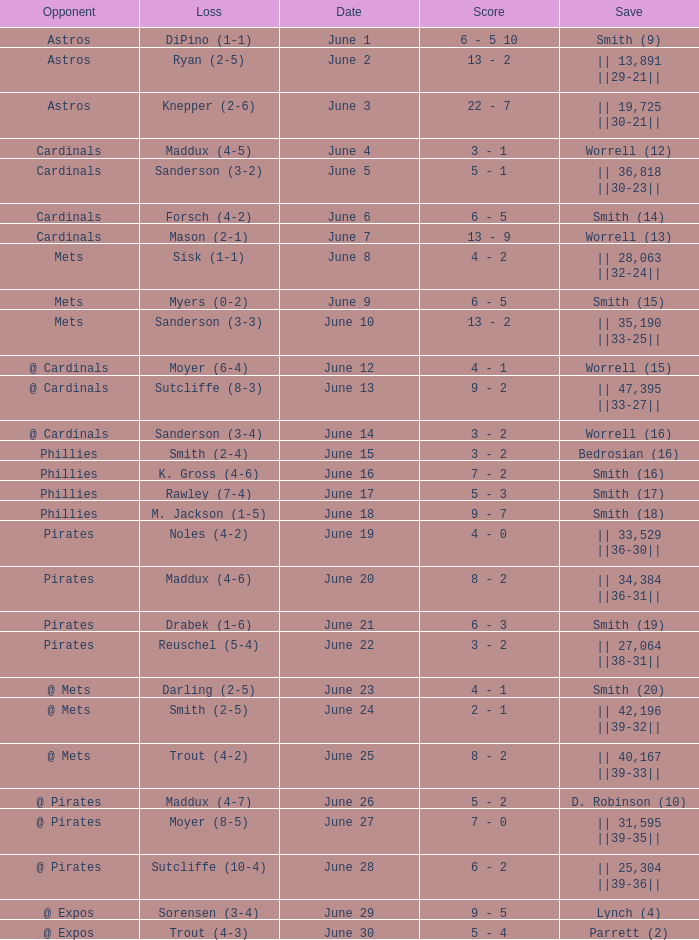What is the loss for the game against @ expos, with a save of parrett (2)? Trout (4-3). 